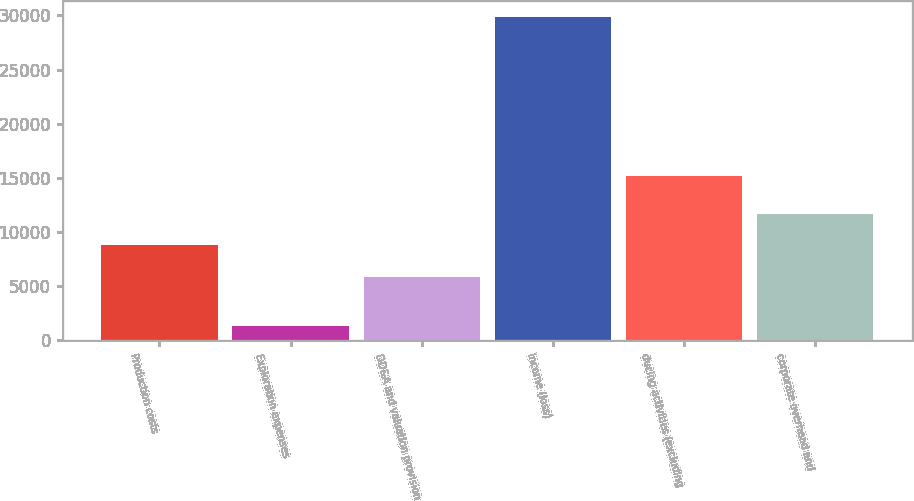Convert chart to OTSL. <chart><loc_0><loc_0><loc_500><loc_500><bar_chart><fcel>Production costs<fcel>Exploration expenses<fcel>DD&A and valuation provision<fcel>Income (loss)<fcel>ducing activities (excluding<fcel>corporate overhead and<nl><fcel>8840<fcel>1341<fcel>5835<fcel>29814<fcel>15162<fcel>11687.3<nl></chart> 